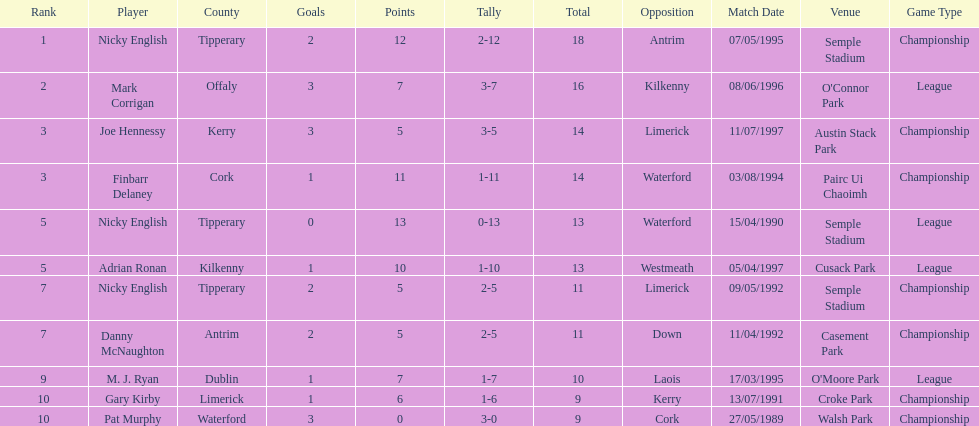Who was the top ranked player in a single game? Nicky English. 